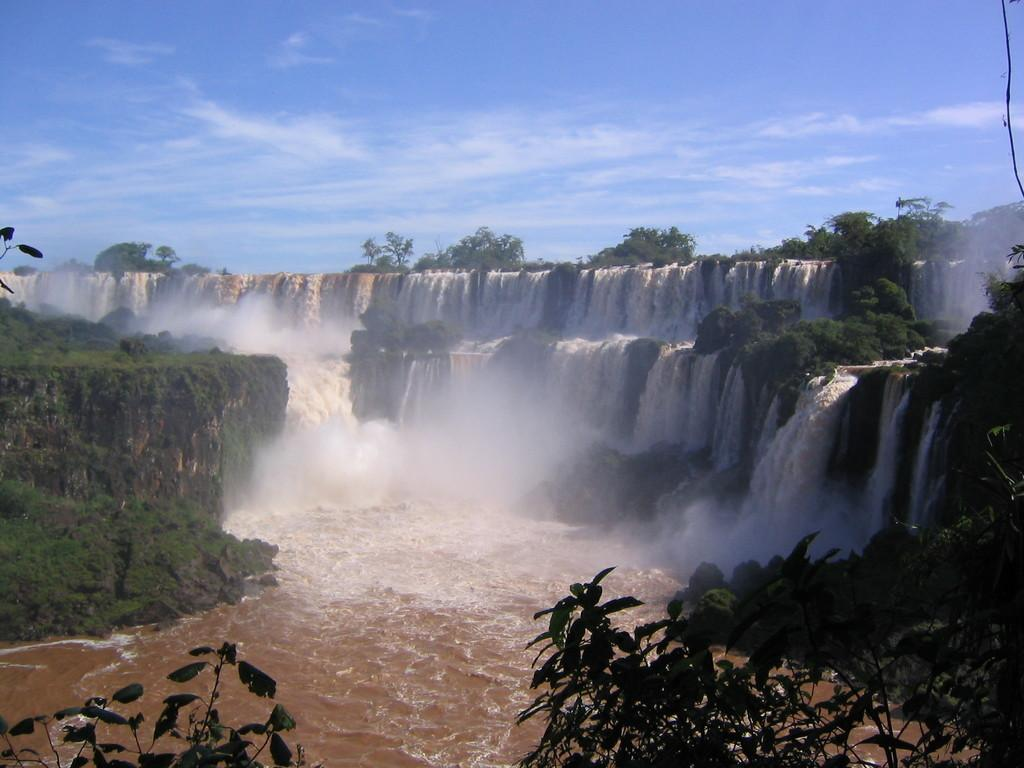What can be seen on both sides of the image? There are plants on both the right and left sides of the image. What natural feature is present in the image? There is a waterfall in the image. What type of vegetation is visible in the background of the image? There are trees in the background of the image. How would you describe the sky in the image? The sky is blue and cloudy in the image. What type of nerve can be seen on the stage in the image? There is no nerve or stage present in the image; it features plants, a waterfall, trees, and a blue, cloudy sky. 